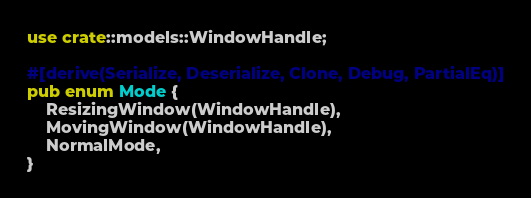Convert code to text. <code><loc_0><loc_0><loc_500><loc_500><_Rust_>use crate::models::WindowHandle;

#[derive(Serialize, Deserialize, Clone, Debug, PartialEq)]
pub enum Mode {
    ResizingWindow(WindowHandle),
    MovingWindow(WindowHandle),
    NormalMode,
}
</code> 